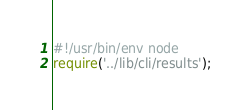Convert code to text. <code><loc_0><loc_0><loc_500><loc_500><_JavaScript_>#!/usr/bin/env node
require('../lib/cli/results');</code> 